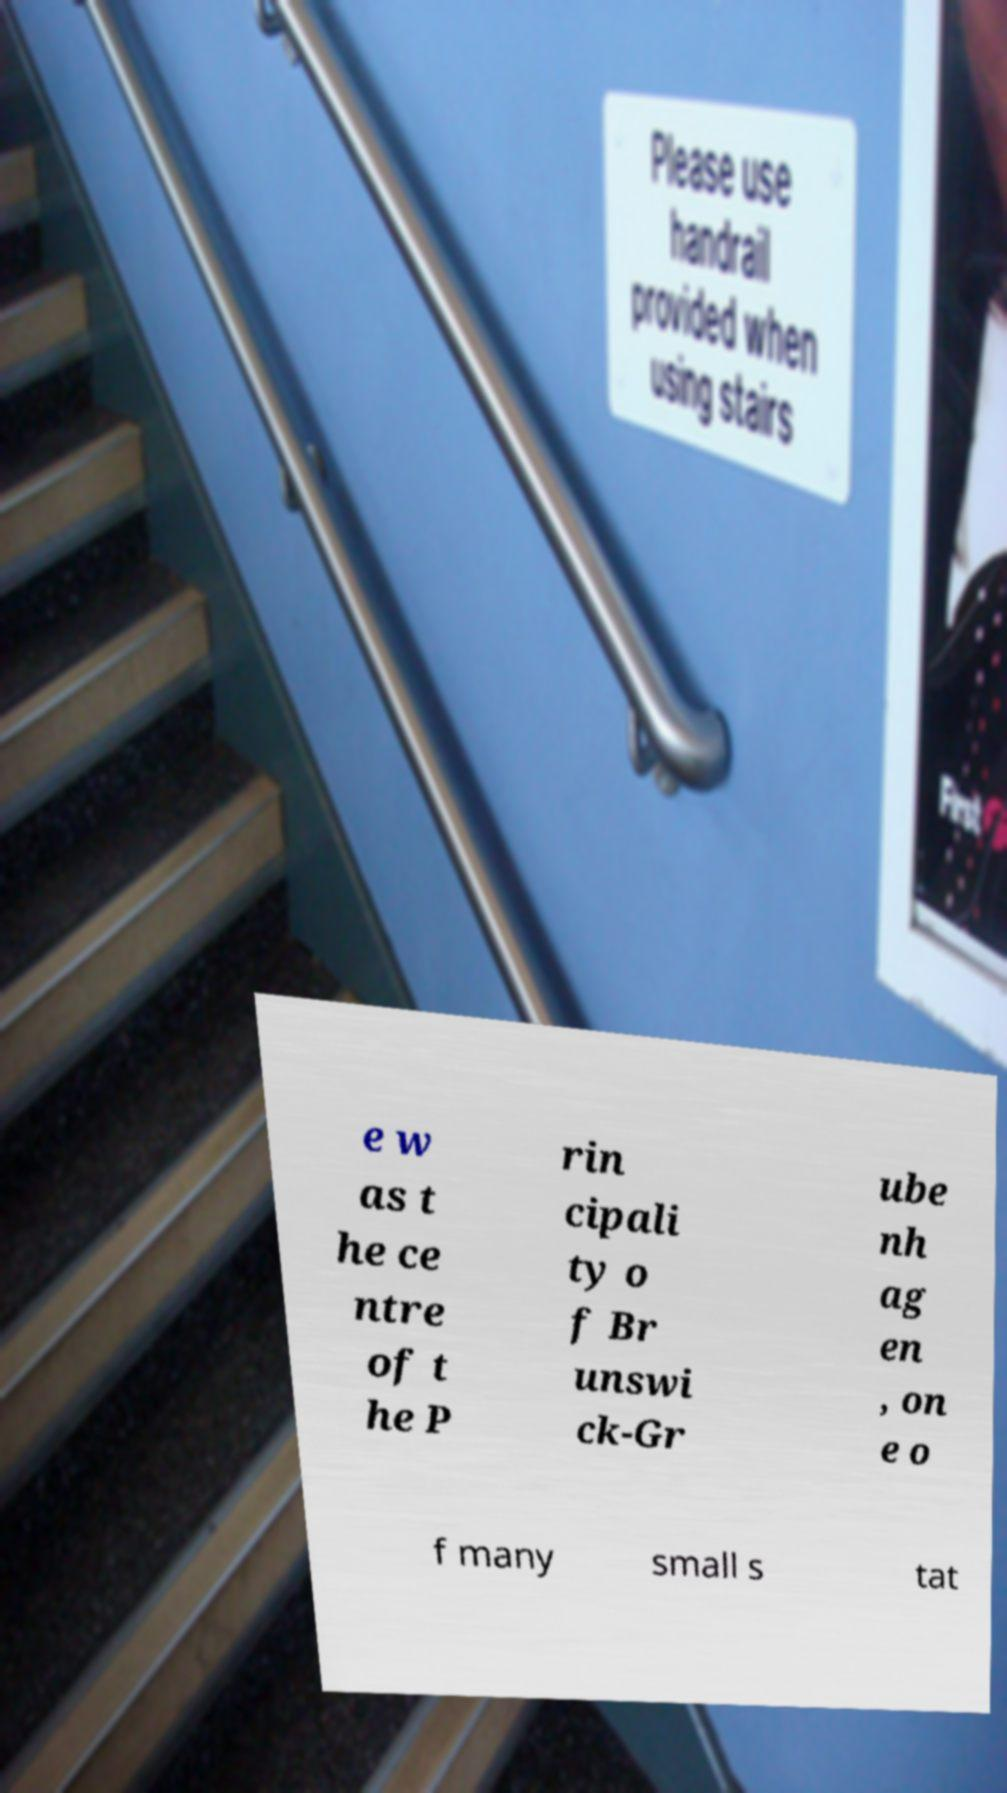I need the written content from this picture converted into text. Can you do that? e w as t he ce ntre of t he P rin cipali ty o f Br unswi ck-Gr ube nh ag en , on e o f many small s tat 